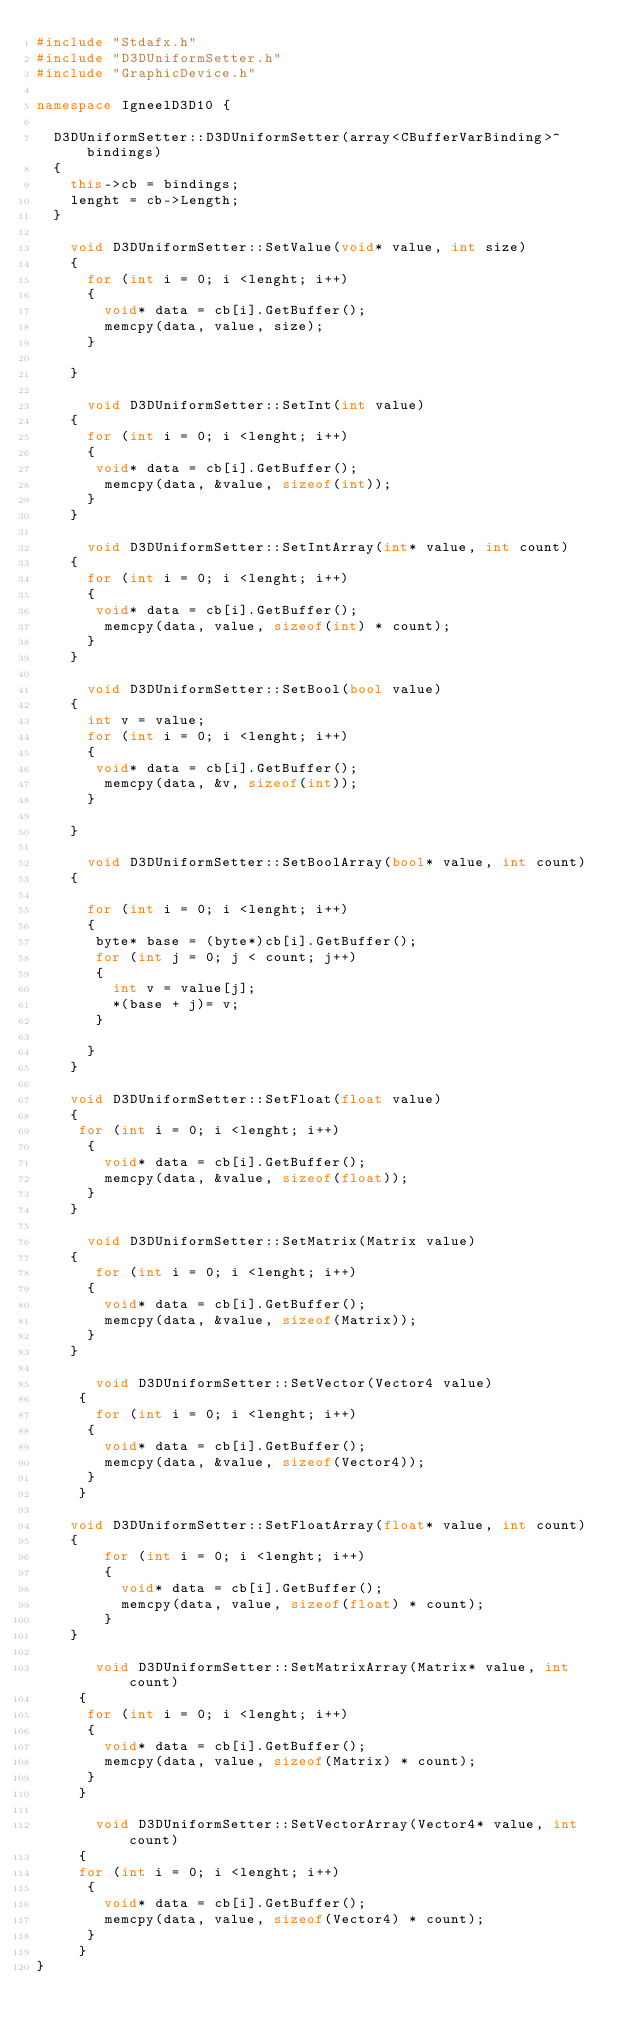<code> <loc_0><loc_0><loc_500><loc_500><_C++_>#include "Stdafx.h"
#include "D3DUniformSetter.h"
#include "GraphicDevice.h"

namespace IgneelD3D10 {

	D3DUniformSetter::D3DUniformSetter(array<CBufferVarBinding>^ bindings)		
	{
		this->cb = bindings;
		lenght = cb->Length;
	}

	  void D3DUniformSetter::SetValue(void* value, int size)
	  {		  
		  for (int i = 0; i <lenght; i++)
		  {
			  void* data = cb[i].GetBuffer();			 
			  memcpy(data, value, size);
		  }
		  
	  }

      void D3DUniformSetter::SetInt(int value)
	  {
		  for (int i = 0; i <lenght; i++)
		  {
			 void* data = cb[i].GetBuffer();			 
			  memcpy(data, &value, sizeof(int));
		  }
	  }

      void D3DUniformSetter::SetIntArray(int* value, int count)
	  {
		  for (int i = 0; i <lenght; i++)
		  {
			 void* data = cb[i].GetBuffer();			 
			  memcpy(data, value, sizeof(int) * count);
		  }
	  }

      void D3DUniformSetter::SetBool(bool value)
	  {
		  int v = value;
		  for (int i = 0; i <lenght; i++)
		  {
			 void* data = cb[i].GetBuffer();			 
			  memcpy(data, &v, sizeof(int));
		  }
		  
	  }

      void D3DUniformSetter::SetBoolArray(bool* value, int count)
	  {
		  
		  for (int i = 0; i <lenght; i++)
		  {
			 byte* base = (byte*)cb[i].GetBuffer();			 			
			 for (int j = 0; j < count; j++)
			 {
				 int v = value[j];
				 *(base + j)= v;
			 }
			 			 
		  }
	  }

	  void D3DUniformSetter::SetFloat(float value)
	  {
		 for (int i = 0; i <lenght; i++)
		  {
			  void* data = cb[i].GetBuffer();			 
			  memcpy(data, &value, sizeof(float));
		  }
	  }

      void D3DUniformSetter::SetMatrix(Matrix value)
	  {
		   for (int i = 0; i <lenght; i++)
		  {
			  void* data = cb[i].GetBuffer();			 
			  memcpy(data, &value, sizeof(Matrix));
		  }
	  }

       void D3DUniformSetter::SetVector(Vector4 value)
	   {
		   for (int i = 0; i <lenght; i++)
		  {
			  void* data = cb[i].GetBuffer();			 
			  memcpy(data, &value, sizeof(Vector4));
		  }
	   }

		void D3DUniformSetter::SetFloatArray(float* value, int count)
		{
			  for (int i = 0; i <lenght; i++)
			  {
				  void* data = cb[i].GetBuffer();			 
				  memcpy(data, value, sizeof(float) * count);
			  }
		}

       void D3DUniformSetter::SetMatrixArray(Matrix* value, int count)
	   {
			for (int i = 0; i <lenght; i++)
			{
				void* data = cb[i].GetBuffer();			 
				memcpy(data, value, sizeof(Matrix) * count);
			}
	   }

       void D3DUniformSetter::SetVectorArray(Vector4* value, int count)
	   {
		 for (int i = 0; i <lenght; i++)
			{
				void* data = cb[i].GetBuffer();			 
				memcpy(data, value, sizeof(Vector4) * count);
			}
	   }	  
}</code> 